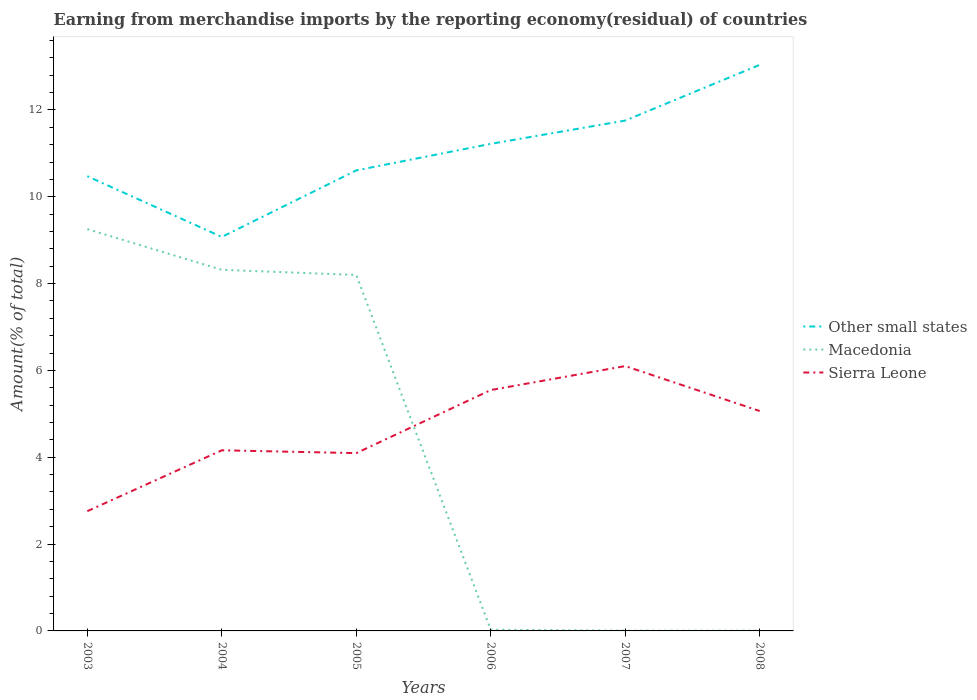Does the line corresponding to Macedonia intersect with the line corresponding to Other small states?
Keep it short and to the point. No. Is the number of lines equal to the number of legend labels?
Keep it short and to the point. Yes. Across all years, what is the maximum percentage of amount earned from merchandise imports in Other small states?
Your answer should be compact. 9.07. In which year was the percentage of amount earned from merchandise imports in Sierra Leone maximum?
Offer a terse response. 2003. What is the total percentage of amount earned from merchandise imports in Macedonia in the graph?
Your response must be concise. 0.12. What is the difference between the highest and the second highest percentage of amount earned from merchandise imports in Macedonia?
Ensure brevity in your answer.  9.25. What is the difference between the highest and the lowest percentage of amount earned from merchandise imports in Other small states?
Give a very brief answer. 3. Is the percentage of amount earned from merchandise imports in Other small states strictly greater than the percentage of amount earned from merchandise imports in Sierra Leone over the years?
Ensure brevity in your answer.  No. How many lines are there?
Provide a succinct answer. 3. How many years are there in the graph?
Provide a succinct answer. 6. Does the graph contain any zero values?
Offer a very short reply. No. Where does the legend appear in the graph?
Provide a short and direct response. Center right. How many legend labels are there?
Your answer should be very brief. 3. How are the legend labels stacked?
Make the answer very short. Vertical. What is the title of the graph?
Offer a very short reply. Earning from merchandise imports by the reporting economy(residual) of countries. Does "Nigeria" appear as one of the legend labels in the graph?
Provide a succinct answer. No. What is the label or title of the X-axis?
Your response must be concise. Years. What is the label or title of the Y-axis?
Your answer should be compact. Amount(% of total). What is the Amount(% of total) in Other small states in 2003?
Provide a short and direct response. 10.47. What is the Amount(% of total) in Macedonia in 2003?
Give a very brief answer. 9.25. What is the Amount(% of total) in Sierra Leone in 2003?
Offer a very short reply. 2.76. What is the Amount(% of total) in Other small states in 2004?
Give a very brief answer. 9.07. What is the Amount(% of total) of Macedonia in 2004?
Your answer should be very brief. 8.32. What is the Amount(% of total) in Sierra Leone in 2004?
Offer a very short reply. 4.16. What is the Amount(% of total) in Other small states in 2005?
Offer a terse response. 10.61. What is the Amount(% of total) in Macedonia in 2005?
Your answer should be compact. 8.2. What is the Amount(% of total) of Sierra Leone in 2005?
Make the answer very short. 4.1. What is the Amount(% of total) in Other small states in 2006?
Make the answer very short. 11.22. What is the Amount(% of total) of Macedonia in 2006?
Ensure brevity in your answer.  0.03. What is the Amount(% of total) in Sierra Leone in 2006?
Your response must be concise. 5.55. What is the Amount(% of total) in Other small states in 2007?
Provide a succinct answer. 11.75. What is the Amount(% of total) in Macedonia in 2007?
Offer a terse response. 0.01. What is the Amount(% of total) in Sierra Leone in 2007?
Your answer should be very brief. 6.1. What is the Amount(% of total) of Other small states in 2008?
Give a very brief answer. 13.04. What is the Amount(% of total) of Macedonia in 2008?
Provide a short and direct response. 0.01. What is the Amount(% of total) in Sierra Leone in 2008?
Provide a short and direct response. 5.07. Across all years, what is the maximum Amount(% of total) of Other small states?
Offer a terse response. 13.04. Across all years, what is the maximum Amount(% of total) in Macedonia?
Ensure brevity in your answer.  9.25. Across all years, what is the maximum Amount(% of total) of Sierra Leone?
Offer a terse response. 6.1. Across all years, what is the minimum Amount(% of total) in Other small states?
Your answer should be compact. 9.07. Across all years, what is the minimum Amount(% of total) of Macedonia?
Offer a terse response. 0.01. Across all years, what is the minimum Amount(% of total) of Sierra Leone?
Keep it short and to the point. 2.76. What is the total Amount(% of total) in Other small states in the graph?
Provide a succinct answer. 66.17. What is the total Amount(% of total) in Macedonia in the graph?
Provide a short and direct response. 25.81. What is the total Amount(% of total) of Sierra Leone in the graph?
Give a very brief answer. 27.73. What is the difference between the Amount(% of total) in Other small states in 2003 and that in 2004?
Provide a short and direct response. 1.4. What is the difference between the Amount(% of total) of Macedonia in 2003 and that in 2004?
Ensure brevity in your answer.  0.94. What is the difference between the Amount(% of total) in Sierra Leone in 2003 and that in 2004?
Your answer should be very brief. -1.4. What is the difference between the Amount(% of total) of Other small states in 2003 and that in 2005?
Give a very brief answer. -0.13. What is the difference between the Amount(% of total) of Macedonia in 2003 and that in 2005?
Your response must be concise. 1.06. What is the difference between the Amount(% of total) in Sierra Leone in 2003 and that in 2005?
Provide a succinct answer. -1.34. What is the difference between the Amount(% of total) in Other small states in 2003 and that in 2006?
Make the answer very short. -0.75. What is the difference between the Amount(% of total) of Macedonia in 2003 and that in 2006?
Offer a terse response. 9.23. What is the difference between the Amount(% of total) in Sierra Leone in 2003 and that in 2006?
Provide a succinct answer. -2.79. What is the difference between the Amount(% of total) in Other small states in 2003 and that in 2007?
Offer a terse response. -1.28. What is the difference between the Amount(% of total) in Macedonia in 2003 and that in 2007?
Provide a succinct answer. 9.25. What is the difference between the Amount(% of total) in Sierra Leone in 2003 and that in 2007?
Ensure brevity in your answer.  -3.34. What is the difference between the Amount(% of total) of Other small states in 2003 and that in 2008?
Make the answer very short. -2.56. What is the difference between the Amount(% of total) of Macedonia in 2003 and that in 2008?
Give a very brief answer. 9.25. What is the difference between the Amount(% of total) in Sierra Leone in 2003 and that in 2008?
Ensure brevity in your answer.  -2.31. What is the difference between the Amount(% of total) of Other small states in 2004 and that in 2005?
Give a very brief answer. -1.53. What is the difference between the Amount(% of total) in Macedonia in 2004 and that in 2005?
Your answer should be compact. 0.12. What is the difference between the Amount(% of total) in Sierra Leone in 2004 and that in 2005?
Your answer should be compact. 0.07. What is the difference between the Amount(% of total) in Other small states in 2004 and that in 2006?
Give a very brief answer. -2.14. What is the difference between the Amount(% of total) in Macedonia in 2004 and that in 2006?
Your answer should be very brief. 8.29. What is the difference between the Amount(% of total) of Sierra Leone in 2004 and that in 2006?
Offer a terse response. -1.39. What is the difference between the Amount(% of total) of Other small states in 2004 and that in 2007?
Make the answer very short. -2.68. What is the difference between the Amount(% of total) of Macedonia in 2004 and that in 2007?
Make the answer very short. 8.31. What is the difference between the Amount(% of total) of Sierra Leone in 2004 and that in 2007?
Offer a very short reply. -1.94. What is the difference between the Amount(% of total) of Other small states in 2004 and that in 2008?
Offer a terse response. -3.96. What is the difference between the Amount(% of total) of Macedonia in 2004 and that in 2008?
Offer a terse response. 8.31. What is the difference between the Amount(% of total) in Sierra Leone in 2004 and that in 2008?
Make the answer very short. -0.9. What is the difference between the Amount(% of total) of Other small states in 2005 and that in 2006?
Provide a short and direct response. -0.61. What is the difference between the Amount(% of total) of Macedonia in 2005 and that in 2006?
Keep it short and to the point. 8.17. What is the difference between the Amount(% of total) in Sierra Leone in 2005 and that in 2006?
Keep it short and to the point. -1.45. What is the difference between the Amount(% of total) of Other small states in 2005 and that in 2007?
Offer a terse response. -1.15. What is the difference between the Amount(% of total) of Macedonia in 2005 and that in 2007?
Offer a terse response. 8.19. What is the difference between the Amount(% of total) in Sierra Leone in 2005 and that in 2007?
Your answer should be very brief. -2. What is the difference between the Amount(% of total) in Other small states in 2005 and that in 2008?
Offer a terse response. -2.43. What is the difference between the Amount(% of total) of Macedonia in 2005 and that in 2008?
Offer a very short reply. 8.19. What is the difference between the Amount(% of total) in Sierra Leone in 2005 and that in 2008?
Ensure brevity in your answer.  -0.97. What is the difference between the Amount(% of total) of Other small states in 2006 and that in 2007?
Keep it short and to the point. -0.54. What is the difference between the Amount(% of total) of Macedonia in 2006 and that in 2007?
Ensure brevity in your answer.  0.02. What is the difference between the Amount(% of total) in Sierra Leone in 2006 and that in 2007?
Offer a terse response. -0.55. What is the difference between the Amount(% of total) in Other small states in 2006 and that in 2008?
Keep it short and to the point. -1.82. What is the difference between the Amount(% of total) of Macedonia in 2006 and that in 2008?
Your answer should be compact. 0.02. What is the difference between the Amount(% of total) in Sierra Leone in 2006 and that in 2008?
Ensure brevity in your answer.  0.48. What is the difference between the Amount(% of total) in Other small states in 2007 and that in 2008?
Provide a short and direct response. -1.28. What is the difference between the Amount(% of total) in Sierra Leone in 2007 and that in 2008?
Offer a terse response. 1.04. What is the difference between the Amount(% of total) in Other small states in 2003 and the Amount(% of total) in Macedonia in 2004?
Your response must be concise. 2.16. What is the difference between the Amount(% of total) in Other small states in 2003 and the Amount(% of total) in Sierra Leone in 2004?
Provide a succinct answer. 6.31. What is the difference between the Amount(% of total) in Macedonia in 2003 and the Amount(% of total) in Sierra Leone in 2004?
Offer a very short reply. 5.09. What is the difference between the Amount(% of total) in Other small states in 2003 and the Amount(% of total) in Macedonia in 2005?
Offer a terse response. 2.28. What is the difference between the Amount(% of total) in Other small states in 2003 and the Amount(% of total) in Sierra Leone in 2005?
Keep it short and to the point. 6.38. What is the difference between the Amount(% of total) in Macedonia in 2003 and the Amount(% of total) in Sierra Leone in 2005?
Your answer should be very brief. 5.16. What is the difference between the Amount(% of total) of Other small states in 2003 and the Amount(% of total) of Macedonia in 2006?
Offer a terse response. 10.44. What is the difference between the Amount(% of total) in Other small states in 2003 and the Amount(% of total) in Sierra Leone in 2006?
Your answer should be very brief. 4.93. What is the difference between the Amount(% of total) of Macedonia in 2003 and the Amount(% of total) of Sierra Leone in 2006?
Your answer should be very brief. 3.71. What is the difference between the Amount(% of total) in Other small states in 2003 and the Amount(% of total) in Macedonia in 2007?
Your answer should be very brief. 10.47. What is the difference between the Amount(% of total) of Other small states in 2003 and the Amount(% of total) of Sierra Leone in 2007?
Give a very brief answer. 4.37. What is the difference between the Amount(% of total) of Macedonia in 2003 and the Amount(% of total) of Sierra Leone in 2007?
Keep it short and to the point. 3.15. What is the difference between the Amount(% of total) of Other small states in 2003 and the Amount(% of total) of Macedonia in 2008?
Provide a short and direct response. 10.47. What is the difference between the Amount(% of total) of Other small states in 2003 and the Amount(% of total) of Sierra Leone in 2008?
Ensure brevity in your answer.  5.41. What is the difference between the Amount(% of total) in Macedonia in 2003 and the Amount(% of total) in Sierra Leone in 2008?
Your answer should be compact. 4.19. What is the difference between the Amount(% of total) in Other small states in 2004 and the Amount(% of total) in Macedonia in 2005?
Your response must be concise. 0.88. What is the difference between the Amount(% of total) of Other small states in 2004 and the Amount(% of total) of Sierra Leone in 2005?
Your answer should be compact. 4.98. What is the difference between the Amount(% of total) in Macedonia in 2004 and the Amount(% of total) in Sierra Leone in 2005?
Ensure brevity in your answer.  4.22. What is the difference between the Amount(% of total) in Other small states in 2004 and the Amount(% of total) in Macedonia in 2006?
Offer a terse response. 9.05. What is the difference between the Amount(% of total) in Other small states in 2004 and the Amount(% of total) in Sierra Leone in 2006?
Offer a very short reply. 3.53. What is the difference between the Amount(% of total) of Macedonia in 2004 and the Amount(% of total) of Sierra Leone in 2006?
Keep it short and to the point. 2.77. What is the difference between the Amount(% of total) in Other small states in 2004 and the Amount(% of total) in Macedonia in 2007?
Ensure brevity in your answer.  9.07. What is the difference between the Amount(% of total) of Other small states in 2004 and the Amount(% of total) of Sierra Leone in 2007?
Your response must be concise. 2.97. What is the difference between the Amount(% of total) of Macedonia in 2004 and the Amount(% of total) of Sierra Leone in 2007?
Provide a succinct answer. 2.22. What is the difference between the Amount(% of total) of Other small states in 2004 and the Amount(% of total) of Macedonia in 2008?
Make the answer very short. 9.07. What is the difference between the Amount(% of total) of Other small states in 2004 and the Amount(% of total) of Sierra Leone in 2008?
Provide a succinct answer. 4.01. What is the difference between the Amount(% of total) in Macedonia in 2004 and the Amount(% of total) in Sierra Leone in 2008?
Keep it short and to the point. 3.25. What is the difference between the Amount(% of total) of Other small states in 2005 and the Amount(% of total) of Macedonia in 2006?
Provide a succinct answer. 10.58. What is the difference between the Amount(% of total) in Other small states in 2005 and the Amount(% of total) in Sierra Leone in 2006?
Offer a terse response. 5.06. What is the difference between the Amount(% of total) in Macedonia in 2005 and the Amount(% of total) in Sierra Leone in 2006?
Provide a succinct answer. 2.65. What is the difference between the Amount(% of total) of Other small states in 2005 and the Amount(% of total) of Macedonia in 2007?
Keep it short and to the point. 10.6. What is the difference between the Amount(% of total) in Other small states in 2005 and the Amount(% of total) in Sierra Leone in 2007?
Ensure brevity in your answer.  4.51. What is the difference between the Amount(% of total) in Macedonia in 2005 and the Amount(% of total) in Sierra Leone in 2007?
Your answer should be very brief. 2.1. What is the difference between the Amount(% of total) of Other small states in 2005 and the Amount(% of total) of Macedonia in 2008?
Make the answer very short. 10.6. What is the difference between the Amount(% of total) of Other small states in 2005 and the Amount(% of total) of Sierra Leone in 2008?
Your response must be concise. 5.54. What is the difference between the Amount(% of total) of Macedonia in 2005 and the Amount(% of total) of Sierra Leone in 2008?
Provide a short and direct response. 3.13. What is the difference between the Amount(% of total) in Other small states in 2006 and the Amount(% of total) in Macedonia in 2007?
Give a very brief answer. 11.21. What is the difference between the Amount(% of total) of Other small states in 2006 and the Amount(% of total) of Sierra Leone in 2007?
Make the answer very short. 5.12. What is the difference between the Amount(% of total) of Macedonia in 2006 and the Amount(% of total) of Sierra Leone in 2007?
Your answer should be very brief. -6.07. What is the difference between the Amount(% of total) in Other small states in 2006 and the Amount(% of total) in Macedonia in 2008?
Your answer should be compact. 11.21. What is the difference between the Amount(% of total) in Other small states in 2006 and the Amount(% of total) in Sierra Leone in 2008?
Offer a terse response. 6.15. What is the difference between the Amount(% of total) in Macedonia in 2006 and the Amount(% of total) in Sierra Leone in 2008?
Your response must be concise. -5.04. What is the difference between the Amount(% of total) of Other small states in 2007 and the Amount(% of total) of Macedonia in 2008?
Give a very brief answer. 11.75. What is the difference between the Amount(% of total) of Other small states in 2007 and the Amount(% of total) of Sierra Leone in 2008?
Make the answer very short. 6.69. What is the difference between the Amount(% of total) in Macedonia in 2007 and the Amount(% of total) in Sierra Leone in 2008?
Give a very brief answer. -5.06. What is the average Amount(% of total) of Other small states per year?
Keep it short and to the point. 11.03. What is the average Amount(% of total) of Macedonia per year?
Offer a very short reply. 4.3. What is the average Amount(% of total) in Sierra Leone per year?
Keep it short and to the point. 4.62. In the year 2003, what is the difference between the Amount(% of total) in Other small states and Amount(% of total) in Macedonia?
Your answer should be compact. 1.22. In the year 2003, what is the difference between the Amount(% of total) of Other small states and Amount(% of total) of Sierra Leone?
Provide a short and direct response. 7.72. In the year 2003, what is the difference between the Amount(% of total) in Macedonia and Amount(% of total) in Sierra Leone?
Keep it short and to the point. 6.5. In the year 2004, what is the difference between the Amount(% of total) of Other small states and Amount(% of total) of Macedonia?
Offer a very short reply. 0.76. In the year 2004, what is the difference between the Amount(% of total) in Other small states and Amount(% of total) in Sierra Leone?
Provide a succinct answer. 4.91. In the year 2004, what is the difference between the Amount(% of total) in Macedonia and Amount(% of total) in Sierra Leone?
Provide a succinct answer. 4.16. In the year 2005, what is the difference between the Amount(% of total) of Other small states and Amount(% of total) of Macedonia?
Provide a short and direct response. 2.41. In the year 2005, what is the difference between the Amount(% of total) in Other small states and Amount(% of total) in Sierra Leone?
Keep it short and to the point. 6.51. In the year 2005, what is the difference between the Amount(% of total) of Macedonia and Amount(% of total) of Sierra Leone?
Keep it short and to the point. 4.1. In the year 2006, what is the difference between the Amount(% of total) in Other small states and Amount(% of total) in Macedonia?
Your response must be concise. 11.19. In the year 2006, what is the difference between the Amount(% of total) of Other small states and Amount(% of total) of Sierra Leone?
Your answer should be compact. 5.67. In the year 2006, what is the difference between the Amount(% of total) of Macedonia and Amount(% of total) of Sierra Leone?
Provide a short and direct response. -5.52. In the year 2007, what is the difference between the Amount(% of total) of Other small states and Amount(% of total) of Macedonia?
Give a very brief answer. 11.75. In the year 2007, what is the difference between the Amount(% of total) of Other small states and Amount(% of total) of Sierra Leone?
Give a very brief answer. 5.65. In the year 2007, what is the difference between the Amount(% of total) of Macedonia and Amount(% of total) of Sierra Leone?
Offer a very short reply. -6.09. In the year 2008, what is the difference between the Amount(% of total) of Other small states and Amount(% of total) of Macedonia?
Ensure brevity in your answer.  13.03. In the year 2008, what is the difference between the Amount(% of total) of Other small states and Amount(% of total) of Sierra Leone?
Your answer should be compact. 7.97. In the year 2008, what is the difference between the Amount(% of total) of Macedonia and Amount(% of total) of Sierra Leone?
Keep it short and to the point. -5.06. What is the ratio of the Amount(% of total) in Other small states in 2003 to that in 2004?
Keep it short and to the point. 1.15. What is the ratio of the Amount(% of total) in Macedonia in 2003 to that in 2004?
Make the answer very short. 1.11. What is the ratio of the Amount(% of total) in Sierra Leone in 2003 to that in 2004?
Offer a terse response. 0.66. What is the ratio of the Amount(% of total) in Other small states in 2003 to that in 2005?
Ensure brevity in your answer.  0.99. What is the ratio of the Amount(% of total) in Macedonia in 2003 to that in 2005?
Your answer should be very brief. 1.13. What is the ratio of the Amount(% of total) in Sierra Leone in 2003 to that in 2005?
Your answer should be very brief. 0.67. What is the ratio of the Amount(% of total) of Other small states in 2003 to that in 2006?
Offer a very short reply. 0.93. What is the ratio of the Amount(% of total) in Macedonia in 2003 to that in 2006?
Offer a very short reply. 324.4. What is the ratio of the Amount(% of total) in Sierra Leone in 2003 to that in 2006?
Make the answer very short. 0.5. What is the ratio of the Amount(% of total) in Other small states in 2003 to that in 2007?
Keep it short and to the point. 0.89. What is the ratio of the Amount(% of total) in Macedonia in 2003 to that in 2007?
Your answer should be very brief. 1450.96. What is the ratio of the Amount(% of total) of Sierra Leone in 2003 to that in 2007?
Provide a succinct answer. 0.45. What is the ratio of the Amount(% of total) of Other small states in 2003 to that in 2008?
Your response must be concise. 0.8. What is the ratio of the Amount(% of total) of Macedonia in 2003 to that in 2008?
Give a very brief answer. 1561.23. What is the ratio of the Amount(% of total) of Sierra Leone in 2003 to that in 2008?
Give a very brief answer. 0.54. What is the ratio of the Amount(% of total) in Other small states in 2004 to that in 2005?
Provide a succinct answer. 0.86. What is the ratio of the Amount(% of total) of Macedonia in 2004 to that in 2005?
Keep it short and to the point. 1.01. What is the ratio of the Amount(% of total) in Other small states in 2004 to that in 2006?
Ensure brevity in your answer.  0.81. What is the ratio of the Amount(% of total) of Macedonia in 2004 to that in 2006?
Your response must be concise. 291.56. What is the ratio of the Amount(% of total) in Sierra Leone in 2004 to that in 2006?
Your answer should be compact. 0.75. What is the ratio of the Amount(% of total) in Other small states in 2004 to that in 2007?
Give a very brief answer. 0.77. What is the ratio of the Amount(% of total) of Macedonia in 2004 to that in 2007?
Your answer should be compact. 1304.08. What is the ratio of the Amount(% of total) in Sierra Leone in 2004 to that in 2007?
Make the answer very short. 0.68. What is the ratio of the Amount(% of total) of Other small states in 2004 to that in 2008?
Make the answer very short. 0.7. What is the ratio of the Amount(% of total) in Macedonia in 2004 to that in 2008?
Your answer should be compact. 1403.19. What is the ratio of the Amount(% of total) of Sierra Leone in 2004 to that in 2008?
Your answer should be very brief. 0.82. What is the ratio of the Amount(% of total) of Other small states in 2005 to that in 2006?
Provide a succinct answer. 0.95. What is the ratio of the Amount(% of total) in Macedonia in 2005 to that in 2006?
Offer a very short reply. 287.39. What is the ratio of the Amount(% of total) in Sierra Leone in 2005 to that in 2006?
Your answer should be very brief. 0.74. What is the ratio of the Amount(% of total) of Other small states in 2005 to that in 2007?
Provide a succinct answer. 0.9. What is the ratio of the Amount(% of total) in Macedonia in 2005 to that in 2007?
Offer a very short reply. 1285.42. What is the ratio of the Amount(% of total) of Sierra Leone in 2005 to that in 2007?
Provide a short and direct response. 0.67. What is the ratio of the Amount(% of total) in Other small states in 2005 to that in 2008?
Provide a short and direct response. 0.81. What is the ratio of the Amount(% of total) of Macedonia in 2005 to that in 2008?
Provide a succinct answer. 1383.12. What is the ratio of the Amount(% of total) in Sierra Leone in 2005 to that in 2008?
Your answer should be very brief. 0.81. What is the ratio of the Amount(% of total) of Other small states in 2006 to that in 2007?
Give a very brief answer. 0.95. What is the ratio of the Amount(% of total) in Macedonia in 2006 to that in 2007?
Offer a terse response. 4.47. What is the ratio of the Amount(% of total) of Sierra Leone in 2006 to that in 2007?
Offer a terse response. 0.91. What is the ratio of the Amount(% of total) of Other small states in 2006 to that in 2008?
Give a very brief answer. 0.86. What is the ratio of the Amount(% of total) in Macedonia in 2006 to that in 2008?
Provide a short and direct response. 4.81. What is the ratio of the Amount(% of total) of Sierra Leone in 2006 to that in 2008?
Give a very brief answer. 1.1. What is the ratio of the Amount(% of total) in Other small states in 2007 to that in 2008?
Keep it short and to the point. 0.9. What is the ratio of the Amount(% of total) in Macedonia in 2007 to that in 2008?
Keep it short and to the point. 1.08. What is the ratio of the Amount(% of total) of Sierra Leone in 2007 to that in 2008?
Your answer should be compact. 1.2. What is the difference between the highest and the second highest Amount(% of total) of Other small states?
Provide a short and direct response. 1.28. What is the difference between the highest and the second highest Amount(% of total) of Macedonia?
Your answer should be compact. 0.94. What is the difference between the highest and the second highest Amount(% of total) of Sierra Leone?
Offer a very short reply. 0.55. What is the difference between the highest and the lowest Amount(% of total) of Other small states?
Provide a short and direct response. 3.96. What is the difference between the highest and the lowest Amount(% of total) in Macedonia?
Your answer should be very brief. 9.25. What is the difference between the highest and the lowest Amount(% of total) of Sierra Leone?
Make the answer very short. 3.34. 